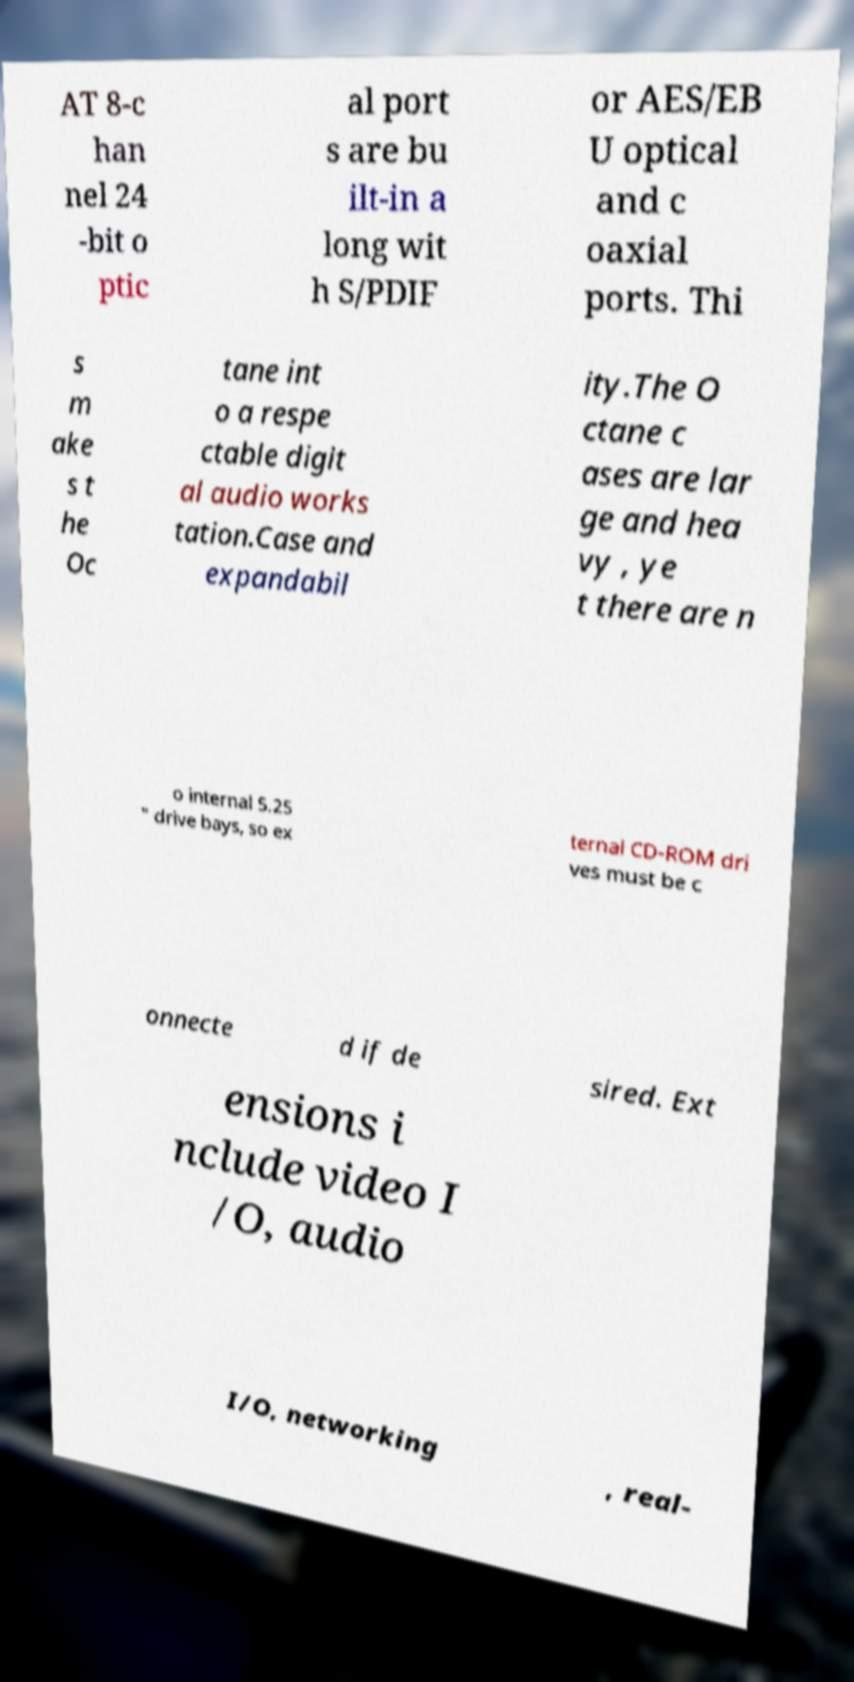Can you read and provide the text displayed in the image?This photo seems to have some interesting text. Can you extract and type it out for me? AT 8-c han nel 24 -bit o ptic al port s are bu ilt-in a long wit h S/PDIF or AES/EB U optical and c oaxial ports. Thi s m ake s t he Oc tane int o a respe ctable digit al audio works tation.Case and expandabil ity.The O ctane c ases are lar ge and hea vy , ye t there are n o internal 5.25 " drive bays, so ex ternal CD-ROM dri ves must be c onnecte d if de sired. Ext ensions i nclude video I /O, audio I/O, networking , real- 